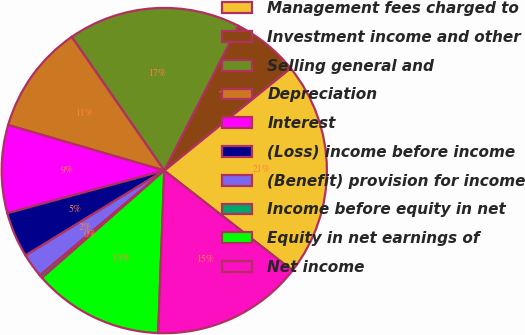Convert chart to OTSL. <chart><loc_0><loc_0><loc_500><loc_500><pie_chart><fcel>Management fees charged to<fcel>Investment income and other<fcel>Selling general and<fcel>Depreciation<fcel>Interest<fcel>(Loss) income before income<fcel>(Benefit) provision for income<fcel>Income before equity in net<fcel>Equity in net earnings of<fcel>Net income<nl><fcel>21.38%<fcel>6.63%<fcel>17.17%<fcel>10.84%<fcel>8.74%<fcel>4.52%<fcel>2.41%<fcel>0.31%<fcel>12.95%<fcel>15.06%<nl></chart> 